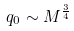Convert formula to latex. <formula><loc_0><loc_0><loc_500><loc_500>q _ { 0 } \sim M ^ { \frac { 3 } { 4 } }</formula> 